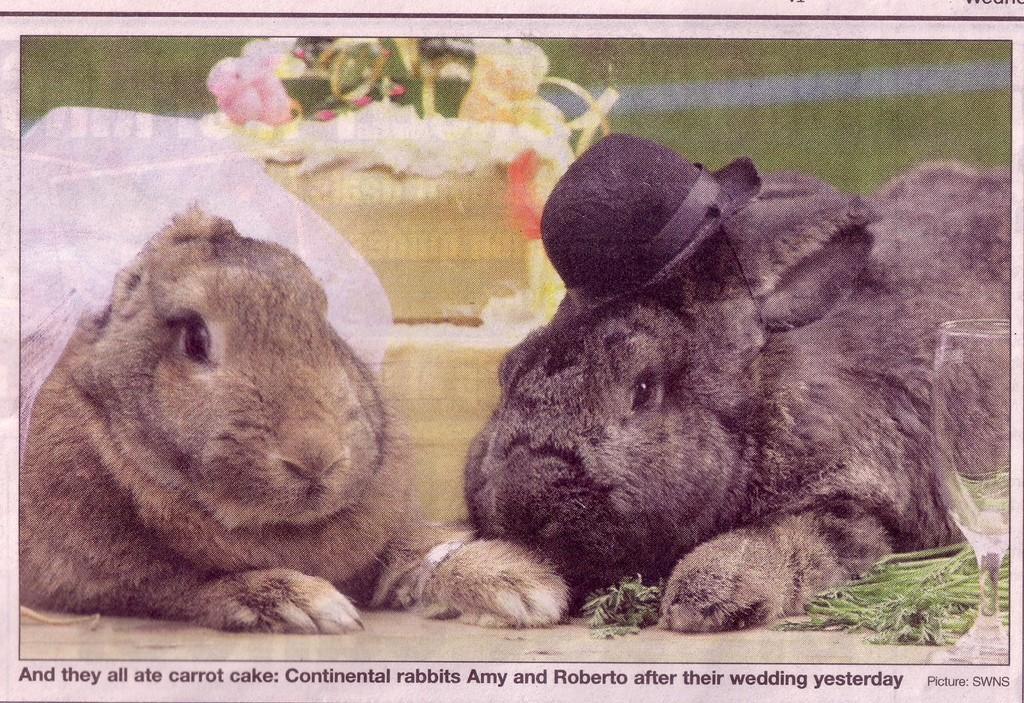Describe this image in one or two sentences. In this image we can see a paper, there are two rabbits sitting on the floor, there is a rabbit wearing a hat, there is a rabbit wearing a cloth, there is an object behind the rabbit that looks like a cake, there are leaves on the floor, there is glass towards the right of the image, there is grass towards the top of the image, there is text towards the bottom of the image. 